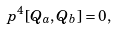Convert formula to latex. <formula><loc_0><loc_0><loc_500><loc_500>p ^ { 4 } [ Q _ { a } , Q _ { b } ] = 0 ,</formula> 